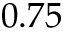Convert formula to latex. <formula><loc_0><loc_0><loc_500><loc_500>0 . 7 5</formula> 